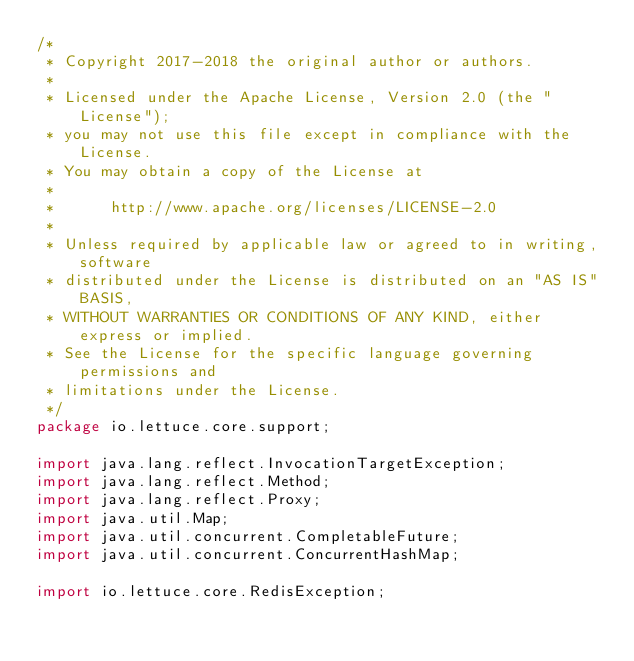Convert code to text. <code><loc_0><loc_0><loc_500><loc_500><_Java_>/*
 * Copyright 2017-2018 the original author or authors.
 *
 * Licensed under the Apache License, Version 2.0 (the "License");
 * you may not use this file except in compliance with the License.
 * You may obtain a copy of the License at
 *
 *      http://www.apache.org/licenses/LICENSE-2.0
 *
 * Unless required by applicable law or agreed to in writing, software
 * distributed under the License is distributed on an "AS IS" BASIS,
 * WITHOUT WARRANTIES OR CONDITIONS OF ANY KIND, either express or implied.
 * See the License for the specific language governing permissions and
 * limitations under the License.
 */
package io.lettuce.core.support;

import java.lang.reflect.InvocationTargetException;
import java.lang.reflect.Method;
import java.lang.reflect.Proxy;
import java.util.Map;
import java.util.concurrent.CompletableFuture;
import java.util.concurrent.ConcurrentHashMap;

import io.lettuce.core.RedisException;</code> 